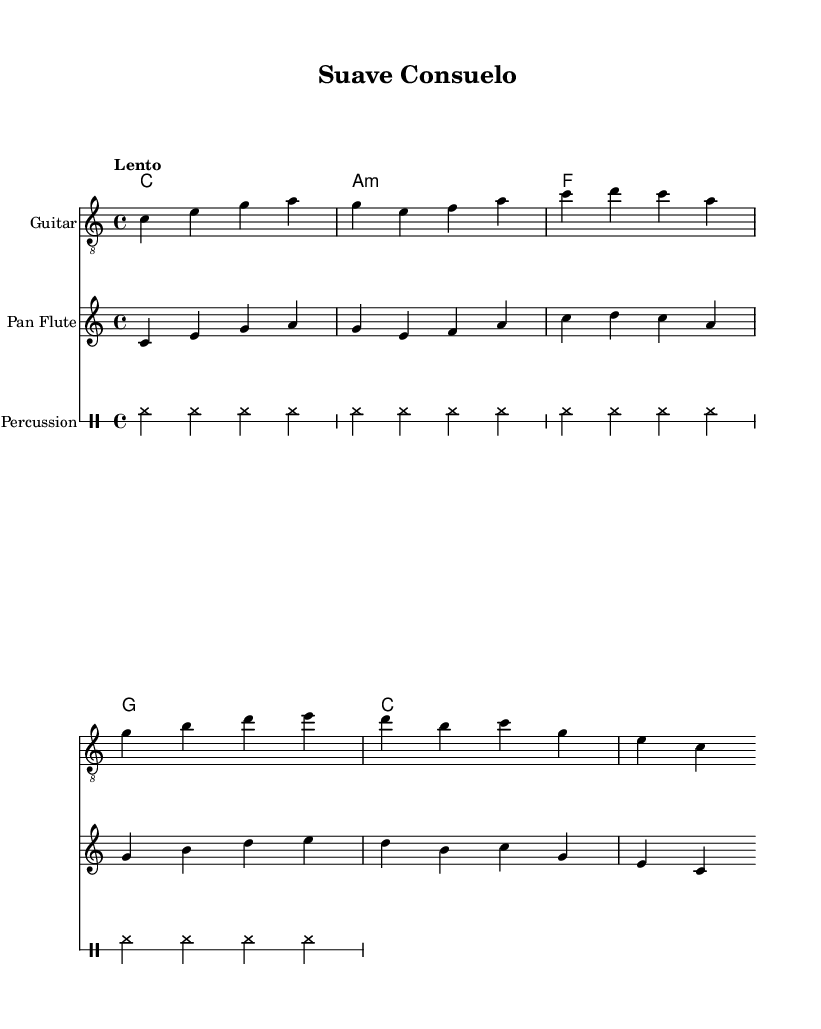What is the key signature of this music? The key signature is C major, which has no sharps or flats indicated at the beginning of the staff.
Answer: C major What is the time signature of this music? The time signature is found at the beginning of the score, which shows 4/4, meaning there are four beats in a measure.
Answer: 4/4 What is the tempo marking for this piece? The tempo is indicated by the word "Lento", which signifies a slow pace for the music.
Answer: Lento How many measures are there in the guitar section? By counting the groups of notes, the guitar section consists of four measures, as indicated by the grouping of notes and bar lines.
Answer: 4 What is the dynamic marking for the percussion part? The dynamic marking is indicated by the term "dynamicUp", which suggests that the percussion should be played with a slightly louder intensity.
Answer: Up What instruments are used in this piece? The instruments are listed in the score as "Guitar," "Pan Flute," and "Percussion," making up the ensemble for the piece.
Answer: Guitar, Pan Flute, Percussion What style of music does this piece represent? The combination of the instrumental arrangement and the tempo, along with the characteristics of the melodies, suggests that this piece is representative of Latin music.
Answer: Latin 